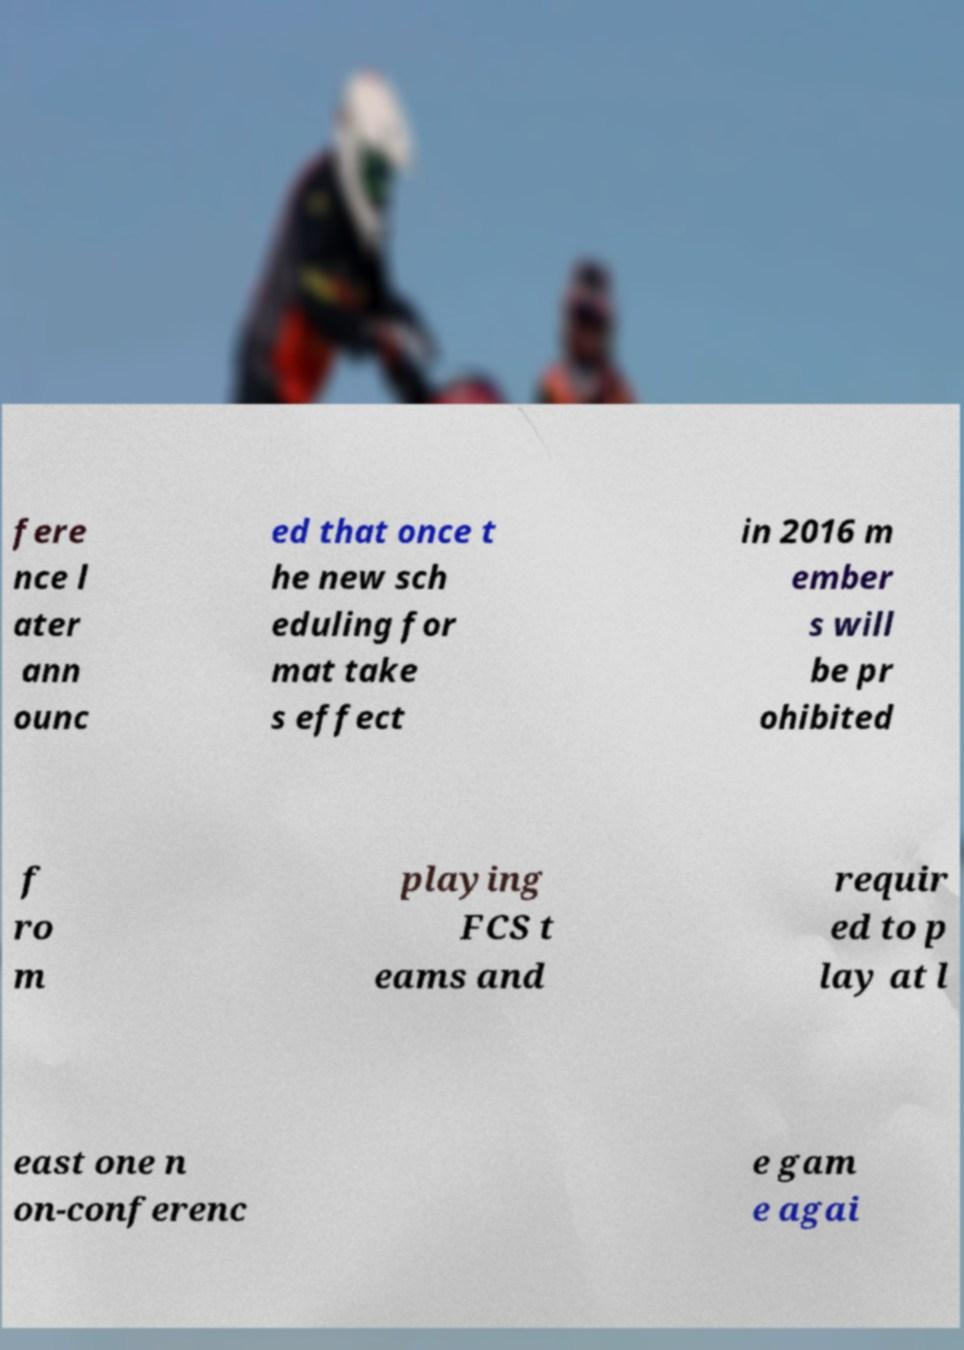Please identify and transcribe the text found in this image. fere nce l ater ann ounc ed that once t he new sch eduling for mat take s effect in 2016 m ember s will be pr ohibited f ro m playing FCS t eams and requir ed to p lay at l east one n on-conferenc e gam e agai 